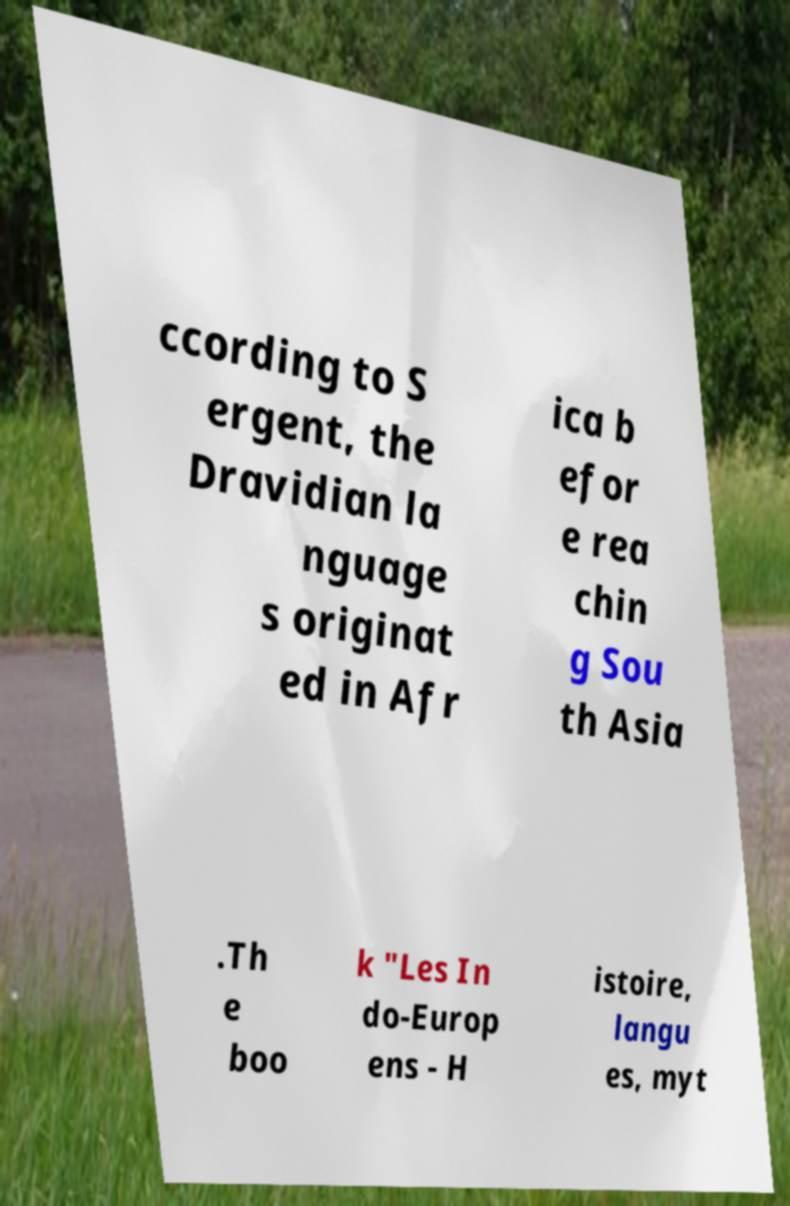Please read and relay the text visible in this image. What does it say? ccording to S ergent, the Dravidian la nguage s originat ed in Afr ica b efor e rea chin g Sou th Asia .Th e boo k "Les In do-Europ ens - H istoire, langu es, myt 